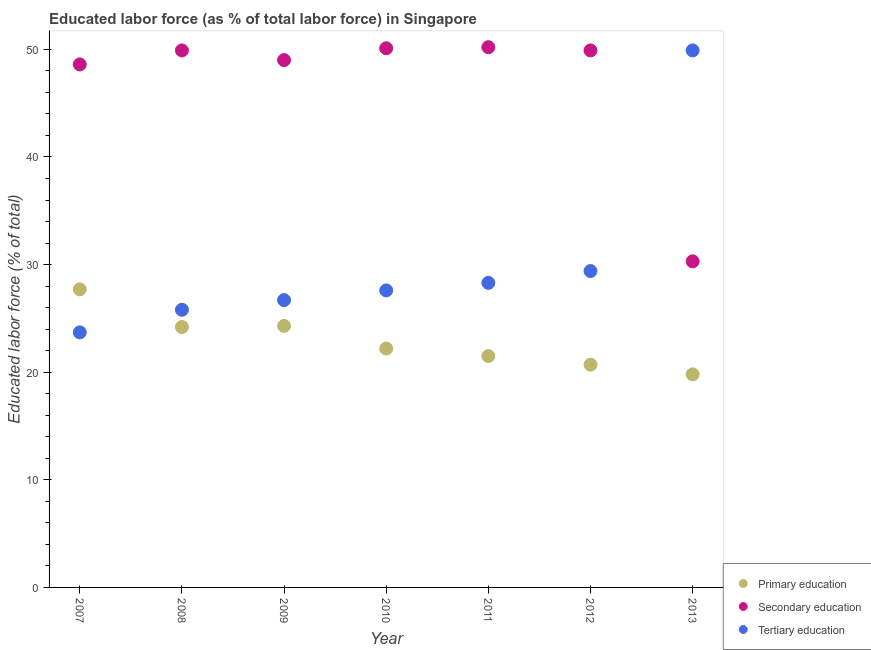What is the percentage of labor force who received primary education in 2008?
Your answer should be very brief. 24.2. Across all years, what is the maximum percentage of labor force who received primary education?
Ensure brevity in your answer.  27.7. Across all years, what is the minimum percentage of labor force who received secondary education?
Your answer should be compact. 30.3. In which year was the percentage of labor force who received secondary education minimum?
Offer a terse response. 2013. What is the total percentage of labor force who received primary education in the graph?
Your answer should be compact. 160.4. What is the difference between the percentage of labor force who received secondary education in 2008 and that in 2010?
Keep it short and to the point. -0.2. What is the difference between the percentage of labor force who received tertiary education in 2007 and the percentage of labor force who received primary education in 2008?
Offer a very short reply. -0.5. What is the average percentage of labor force who received primary education per year?
Ensure brevity in your answer.  22.91. In the year 2008, what is the difference between the percentage of labor force who received secondary education and percentage of labor force who received primary education?
Offer a terse response. 25.7. What is the ratio of the percentage of labor force who received secondary education in 2010 to that in 2013?
Provide a succinct answer. 1.65. What is the difference between the highest and the second highest percentage of labor force who received secondary education?
Offer a very short reply. 0.1. What is the difference between the highest and the lowest percentage of labor force who received tertiary education?
Offer a very short reply. 26.2. In how many years, is the percentage of labor force who received primary education greater than the average percentage of labor force who received primary education taken over all years?
Ensure brevity in your answer.  3. Is it the case that in every year, the sum of the percentage of labor force who received primary education and percentage of labor force who received secondary education is greater than the percentage of labor force who received tertiary education?
Offer a very short reply. Yes. Is the percentage of labor force who received secondary education strictly greater than the percentage of labor force who received tertiary education over the years?
Your answer should be compact. No. Is the percentage of labor force who received tertiary education strictly less than the percentage of labor force who received secondary education over the years?
Ensure brevity in your answer.  No. What is the difference between two consecutive major ticks on the Y-axis?
Make the answer very short. 10. Are the values on the major ticks of Y-axis written in scientific E-notation?
Your answer should be compact. No. Does the graph contain any zero values?
Keep it short and to the point. No. Does the graph contain grids?
Ensure brevity in your answer.  No. Where does the legend appear in the graph?
Offer a very short reply. Bottom right. How many legend labels are there?
Give a very brief answer. 3. How are the legend labels stacked?
Offer a very short reply. Vertical. What is the title of the graph?
Make the answer very short. Educated labor force (as % of total labor force) in Singapore. What is the label or title of the X-axis?
Give a very brief answer. Year. What is the label or title of the Y-axis?
Your answer should be compact. Educated labor force (% of total). What is the Educated labor force (% of total) in Primary education in 2007?
Offer a terse response. 27.7. What is the Educated labor force (% of total) of Secondary education in 2007?
Your answer should be very brief. 48.6. What is the Educated labor force (% of total) in Tertiary education in 2007?
Offer a very short reply. 23.7. What is the Educated labor force (% of total) of Primary education in 2008?
Your response must be concise. 24.2. What is the Educated labor force (% of total) in Secondary education in 2008?
Make the answer very short. 49.9. What is the Educated labor force (% of total) in Tertiary education in 2008?
Make the answer very short. 25.8. What is the Educated labor force (% of total) of Primary education in 2009?
Your answer should be compact. 24.3. What is the Educated labor force (% of total) in Secondary education in 2009?
Your answer should be compact. 49. What is the Educated labor force (% of total) of Tertiary education in 2009?
Your response must be concise. 26.7. What is the Educated labor force (% of total) of Primary education in 2010?
Provide a succinct answer. 22.2. What is the Educated labor force (% of total) of Secondary education in 2010?
Offer a very short reply. 50.1. What is the Educated labor force (% of total) in Tertiary education in 2010?
Your answer should be compact. 27.6. What is the Educated labor force (% of total) in Primary education in 2011?
Provide a short and direct response. 21.5. What is the Educated labor force (% of total) of Secondary education in 2011?
Provide a short and direct response. 50.2. What is the Educated labor force (% of total) of Tertiary education in 2011?
Your answer should be very brief. 28.3. What is the Educated labor force (% of total) in Primary education in 2012?
Offer a terse response. 20.7. What is the Educated labor force (% of total) of Secondary education in 2012?
Make the answer very short. 49.9. What is the Educated labor force (% of total) of Tertiary education in 2012?
Your answer should be compact. 29.4. What is the Educated labor force (% of total) of Primary education in 2013?
Provide a short and direct response. 19.8. What is the Educated labor force (% of total) in Secondary education in 2013?
Your answer should be compact. 30.3. What is the Educated labor force (% of total) in Tertiary education in 2013?
Make the answer very short. 49.9. Across all years, what is the maximum Educated labor force (% of total) in Primary education?
Provide a succinct answer. 27.7. Across all years, what is the maximum Educated labor force (% of total) of Secondary education?
Keep it short and to the point. 50.2. Across all years, what is the maximum Educated labor force (% of total) of Tertiary education?
Keep it short and to the point. 49.9. Across all years, what is the minimum Educated labor force (% of total) of Primary education?
Offer a terse response. 19.8. Across all years, what is the minimum Educated labor force (% of total) in Secondary education?
Your response must be concise. 30.3. Across all years, what is the minimum Educated labor force (% of total) of Tertiary education?
Make the answer very short. 23.7. What is the total Educated labor force (% of total) in Primary education in the graph?
Ensure brevity in your answer.  160.4. What is the total Educated labor force (% of total) in Secondary education in the graph?
Offer a very short reply. 328. What is the total Educated labor force (% of total) in Tertiary education in the graph?
Your response must be concise. 211.4. What is the difference between the Educated labor force (% of total) in Secondary education in 2007 and that in 2009?
Offer a very short reply. -0.4. What is the difference between the Educated labor force (% of total) of Tertiary education in 2007 and that in 2009?
Your response must be concise. -3. What is the difference between the Educated labor force (% of total) of Tertiary education in 2007 and that in 2010?
Provide a short and direct response. -3.9. What is the difference between the Educated labor force (% of total) in Primary education in 2007 and that in 2012?
Keep it short and to the point. 7. What is the difference between the Educated labor force (% of total) in Secondary education in 2007 and that in 2012?
Provide a short and direct response. -1.3. What is the difference between the Educated labor force (% of total) of Primary education in 2007 and that in 2013?
Offer a terse response. 7.9. What is the difference between the Educated labor force (% of total) in Secondary education in 2007 and that in 2013?
Your response must be concise. 18.3. What is the difference between the Educated labor force (% of total) in Tertiary education in 2007 and that in 2013?
Give a very brief answer. -26.2. What is the difference between the Educated labor force (% of total) of Primary education in 2008 and that in 2009?
Offer a terse response. -0.1. What is the difference between the Educated labor force (% of total) in Tertiary education in 2008 and that in 2009?
Keep it short and to the point. -0.9. What is the difference between the Educated labor force (% of total) in Secondary education in 2008 and that in 2010?
Provide a short and direct response. -0.2. What is the difference between the Educated labor force (% of total) of Tertiary education in 2008 and that in 2010?
Provide a short and direct response. -1.8. What is the difference between the Educated labor force (% of total) of Primary education in 2008 and that in 2011?
Ensure brevity in your answer.  2.7. What is the difference between the Educated labor force (% of total) of Tertiary education in 2008 and that in 2011?
Ensure brevity in your answer.  -2.5. What is the difference between the Educated labor force (% of total) of Primary education in 2008 and that in 2012?
Give a very brief answer. 3.5. What is the difference between the Educated labor force (% of total) in Tertiary education in 2008 and that in 2012?
Offer a very short reply. -3.6. What is the difference between the Educated labor force (% of total) of Secondary education in 2008 and that in 2013?
Keep it short and to the point. 19.6. What is the difference between the Educated labor force (% of total) in Tertiary education in 2008 and that in 2013?
Ensure brevity in your answer.  -24.1. What is the difference between the Educated labor force (% of total) of Primary education in 2009 and that in 2010?
Make the answer very short. 2.1. What is the difference between the Educated labor force (% of total) in Secondary education in 2009 and that in 2010?
Your answer should be very brief. -1.1. What is the difference between the Educated labor force (% of total) of Tertiary education in 2009 and that in 2010?
Keep it short and to the point. -0.9. What is the difference between the Educated labor force (% of total) of Primary education in 2009 and that in 2012?
Your answer should be very brief. 3.6. What is the difference between the Educated labor force (% of total) in Primary education in 2009 and that in 2013?
Your answer should be very brief. 4.5. What is the difference between the Educated labor force (% of total) in Tertiary education in 2009 and that in 2013?
Your answer should be very brief. -23.2. What is the difference between the Educated labor force (% of total) of Secondary education in 2010 and that in 2011?
Ensure brevity in your answer.  -0.1. What is the difference between the Educated labor force (% of total) of Secondary education in 2010 and that in 2012?
Give a very brief answer. 0.2. What is the difference between the Educated labor force (% of total) in Tertiary education in 2010 and that in 2012?
Offer a very short reply. -1.8. What is the difference between the Educated labor force (% of total) of Primary education in 2010 and that in 2013?
Give a very brief answer. 2.4. What is the difference between the Educated labor force (% of total) of Secondary education in 2010 and that in 2013?
Give a very brief answer. 19.8. What is the difference between the Educated labor force (% of total) in Tertiary education in 2010 and that in 2013?
Ensure brevity in your answer.  -22.3. What is the difference between the Educated labor force (% of total) in Secondary education in 2011 and that in 2012?
Your answer should be compact. 0.3. What is the difference between the Educated labor force (% of total) of Tertiary education in 2011 and that in 2012?
Provide a short and direct response. -1.1. What is the difference between the Educated labor force (% of total) in Primary education in 2011 and that in 2013?
Provide a short and direct response. 1.7. What is the difference between the Educated labor force (% of total) in Secondary education in 2011 and that in 2013?
Your answer should be compact. 19.9. What is the difference between the Educated labor force (% of total) in Tertiary education in 2011 and that in 2013?
Offer a very short reply. -21.6. What is the difference between the Educated labor force (% of total) of Primary education in 2012 and that in 2013?
Ensure brevity in your answer.  0.9. What is the difference between the Educated labor force (% of total) of Secondary education in 2012 and that in 2013?
Your answer should be compact. 19.6. What is the difference between the Educated labor force (% of total) of Tertiary education in 2012 and that in 2013?
Provide a succinct answer. -20.5. What is the difference between the Educated labor force (% of total) of Primary education in 2007 and the Educated labor force (% of total) of Secondary education in 2008?
Provide a succinct answer. -22.2. What is the difference between the Educated labor force (% of total) in Primary education in 2007 and the Educated labor force (% of total) in Tertiary education in 2008?
Keep it short and to the point. 1.9. What is the difference between the Educated labor force (% of total) in Secondary education in 2007 and the Educated labor force (% of total) in Tertiary education in 2008?
Make the answer very short. 22.8. What is the difference between the Educated labor force (% of total) in Primary education in 2007 and the Educated labor force (% of total) in Secondary education in 2009?
Your answer should be compact. -21.3. What is the difference between the Educated labor force (% of total) of Primary education in 2007 and the Educated labor force (% of total) of Tertiary education in 2009?
Provide a short and direct response. 1. What is the difference between the Educated labor force (% of total) in Secondary education in 2007 and the Educated labor force (% of total) in Tertiary education in 2009?
Provide a succinct answer. 21.9. What is the difference between the Educated labor force (% of total) in Primary education in 2007 and the Educated labor force (% of total) in Secondary education in 2010?
Give a very brief answer. -22.4. What is the difference between the Educated labor force (% of total) of Primary education in 2007 and the Educated labor force (% of total) of Tertiary education in 2010?
Your response must be concise. 0.1. What is the difference between the Educated labor force (% of total) of Primary education in 2007 and the Educated labor force (% of total) of Secondary education in 2011?
Give a very brief answer. -22.5. What is the difference between the Educated labor force (% of total) in Primary education in 2007 and the Educated labor force (% of total) in Tertiary education in 2011?
Make the answer very short. -0.6. What is the difference between the Educated labor force (% of total) in Secondary education in 2007 and the Educated labor force (% of total) in Tertiary education in 2011?
Keep it short and to the point. 20.3. What is the difference between the Educated labor force (% of total) in Primary education in 2007 and the Educated labor force (% of total) in Secondary education in 2012?
Give a very brief answer. -22.2. What is the difference between the Educated labor force (% of total) of Secondary education in 2007 and the Educated labor force (% of total) of Tertiary education in 2012?
Your answer should be compact. 19.2. What is the difference between the Educated labor force (% of total) of Primary education in 2007 and the Educated labor force (% of total) of Tertiary education in 2013?
Your answer should be compact. -22.2. What is the difference between the Educated labor force (% of total) in Primary education in 2008 and the Educated labor force (% of total) in Secondary education in 2009?
Give a very brief answer. -24.8. What is the difference between the Educated labor force (% of total) of Primary education in 2008 and the Educated labor force (% of total) of Tertiary education in 2009?
Offer a very short reply. -2.5. What is the difference between the Educated labor force (% of total) in Secondary education in 2008 and the Educated labor force (% of total) in Tertiary education in 2009?
Ensure brevity in your answer.  23.2. What is the difference between the Educated labor force (% of total) in Primary education in 2008 and the Educated labor force (% of total) in Secondary education in 2010?
Your response must be concise. -25.9. What is the difference between the Educated labor force (% of total) in Secondary education in 2008 and the Educated labor force (% of total) in Tertiary education in 2010?
Your answer should be very brief. 22.3. What is the difference between the Educated labor force (% of total) of Primary education in 2008 and the Educated labor force (% of total) of Secondary education in 2011?
Make the answer very short. -26. What is the difference between the Educated labor force (% of total) of Primary education in 2008 and the Educated labor force (% of total) of Tertiary education in 2011?
Offer a very short reply. -4.1. What is the difference between the Educated labor force (% of total) in Secondary education in 2008 and the Educated labor force (% of total) in Tertiary education in 2011?
Your answer should be compact. 21.6. What is the difference between the Educated labor force (% of total) of Primary education in 2008 and the Educated labor force (% of total) of Secondary education in 2012?
Your answer should be very brief. -25.7. What is the difference between the Educated labor force (% of total) of Primary education in 2008 and the Educated labor force (% of total) of Secondary education in 2013?
Your answer should be very brief. -6.1. What is the difference between the Educated labor force (% of total) of Primary education in 2008 and the Educated labor force (% of total) of Tertiary education in 2013?
Provide a succinct answer. -25.7. What is the difference between the Educated labor force (% of total) of Secondary education in 2008 and the Educated labor force (% of total) of Tertiary education in 2013?
Your answer should be compact. 0. What is the difference between the Educated labor force (% of total) of Primary education in 2009 and the Educated labor force (% of total) of Secondary education in 2010?
Your response must be concise. -25.8. What is the difference between the Educated labor force (% of total) of Primary education in 2009 and the Educated labor force (% of total) of Tertiary education in 2010?
Provide a succinct answer. -3.3. What is the difference between the Educated labor force (% of total) in Secondary education in 2009 and the Educated labor force (% of total) in Tertiary education in 2010?
Your response must be concise. 21.4. What is the difference between the Educated labor force (% of total) of Primary education in 2009 and the Educated labor force (% of total) of Secondary education in 2011?
Keep it short and to the point. -25.9. What is the difference between the Educated labor force (% of total) of Primary education in 2009 and the Educated labor force (% of total) of Tertiary education in 2011?
Your answer should be compact. -4. What is the difference between the Educated labor force (% of total) of Secondary education in 2009 and the Educated labor force (% of total) of Tertiary education in 2011?
Your answer should be very brief. 20.7. What is the difference between the Educated labor force (% of total) of Primary education in 2009 and the Educated labor force (% of total) of Secondary education in 2012?
Keep it short and to the point. -25.6. What is the difference between the Educated labor force (% of total) in Primary education in 2009 and the Educated labor force (% of total) in Tertiary education in 2012?
Make the answer very short. -5.1. What is the difference between the Educated labor force (% of total) in Secondary education in 2009 and the Educated labor force (% of total) in Tertiary education in 2012?
Offer a terse response. 19.6. What is the difference between the Educated labor force (% of total) of Primary education in 2009 and the Educated labor force (% of total) of Secondary education in 2013?
Make the answer very short. -6. What is the difference between the Educated labor force (% of total) of Primary education in 2009 and the Educated labor force (% of total) of Tertiary education in 2013?
Make the answer very short. -25.6. What is the difference between the Educated labor force (% of total) in Secondary education in 2009 and the Educated labor force (% of total) in Tertiary education in 2013?
Make the answer very short. -0.9. What is the difference between the Educated labor force (% of total) of Secondary education in 2010 and the Educated labor force (% of total) of Tertiary education in 2011?
Your answer should be compact. 21.8. What is the difference between the Educated labor force (% of total) of Primary education in 2010 and the Educated labor force (% of total) of Secondary education in 2012?
Your answer should be very brief. -27.7. What is the difference between the Educated labor force (% of total) of Primary education in 2010 and the Educated labor force (% of total) of Tertiary education in 2012?
Ensure brevity in your answer.  -7.2. What is the difference between the Educated labor force (% of total) in Secondary education in 2010 and the Educated labor force (% of total) in Tertiary education in 2012?
Provide a short and direct response. 20.7. What is the difference between the Educated labor force (% of total) of Primary education in 2010 and the Educated labor force (% of total) of Tertiary education in 2013?
Provide a succinct answer. -27.7. What is the difference between the Educated labor force (% of total) of Primary education in 2011 and the Educated labor force (% of total) of Secondary education in 2012?
Make the answer very short. -28.4. What is the difference between the Educated labor force (% of total) in Secondary education in 2011 and the Educated labor force (% of total) in Tertiary education in 2012?
Provide a succinct answer. 20.8. What is the difference between the Educated labor force (% of total) in Primary education in 2011 and the Educated labor force (% of total) in Tertiary education in 2013?
Provide a succinct answer. -28.4. What is the difference between the Educated labor force (% of total) in Primary education in 2012 and the Educated labor force (% of total) in Tertiary education in 2013?
Keep it short and to the point. -29.2. What is the difference between the Educated labor force (% of total) of Secondary education in 2012 and the Educated labor force (% of total) of Tertiary education in 2013?
Provide a short and direct response. 0. What is the average Educated labor force (% of total) in Primary education per year?
Make the answer very short. 22.91. What is the average Educated labor force (% of total) of Secondary education per year?
Give a very brief answer. 46.86. What is the average Educated labor force (% of total) in Tertiary education per year?
Give a very brief answer. 30.2. In the year 2007, what is the difference between the Educated labor force (% of total) in Primary education and Educated labor force (% of total) in Secondary education?
Provide a short and direct response. -20.9. In the year 2007, what is the difference between the Educated labor force (% of total) of Secondary education and Educated labor force (% of total) of Tertiary education?
Your response must be concise. 24.9. In the year 2008, what is the difference between the Educated labor force (% of total) in Primary education and Educated labor force (% of total) in Secondary education?
Offer a terse response. -25.7. In the year 2008, what is the difference between the Educated labor force (% of total) of Secondary education and Educated labor force (% of total) of Tertiary education?
Offer a terse response. 24.1. In the year 2009, what is the difference between the Educated labor force (% of total) of Primary education and Educated labor force (% of total) of Secondary education?
Give a very brief answer. -24.7. In the year 2009, what is the difference between the Educated labor force (% of total) in Primary education and Educated labor force (% of total) in Tertiary education?
Provide a short and direct response. -2.4. In the year 2009, what is the difference between the Educated labor force (% of total) of Secondary education and Educated labor force (% of total) of Tertiary education?
Give a very brief answer. 22.3. In the year 2010, what is the difference between the Educated labor force (% of total) in Primary education and Educated labor force (% of total) in Secondary education?
Offer a terse response. -27.9. In the year 2011, what is the difference between the Educated labor force (% of total) of Primary education and Educated labor force (% of total) of Secondary education?
Make the answer very short. -28.7. In the year 2011, what is the difference between the Educated labor force (% of total) in Secondary education and Educated labor force (% of total) in Tertiary education?
Your answer should be compact. 21.9. In the year 2012, what is the difference between the Educated labor force (% of total) in Primary education and Educated labor force (% of total) in Secondary education?
Offer a terse response. -29.2. In the year 2012, what is the difference between the Educated labor force (% of total) of Secondary education and Educated labor force (% of total) of Tertiary education?
Provide a short and direct response. 20.5. In the year 2013, what is the difference between the Educated labor force (% of total) in Primary education and Educated labor force (% of total) in Secondary education?
Give a very brief answer. -10.5. In the year 2013, what is the difference between the Educated labor force (% of total) of Primary education and Educated labor force (% of total) of Tertiary education?
Provide a short and direct response. -30.1. In the year 2013, what is the difference between the Educated labor force (% of total) of Secondary education and Educated labor force (% of total) of Tertiary education?
Make the answer very short. -19.6. What is the ratio of the Educated labor force (% of total) of Primary education in 2007 to that in 2008?
Provide a succinct answer. 1.14. What is the ratio of the Educated labor force (% of total) of Secondary education in 2007 to that in 2008?
Give a very brief answer. 0.97. What is the ratio of the Educated labor force (% of total) of Tertiary education in 2007 to that in 2008?
Make the answer very short. 0.92. What is the ratio of the Educated labor force (% of total) in Primary education in 2007 to that in 2009?
Offer a terse response. 1.14. What is the ratio of the Educated labor force (% of total) in Tertiary education in 2007 to that in 2009?
Ensure brevity in your answer.  0.89. What is the ratio of the Educated labor force (% of total) of Primary education in 2007 to that in 2010?
Your answer should be compact. 1.25. What is the ratio of the Educated labor force (% of total) in Secondary education in 2007 to that in 2010?
Ensure brevity in your answer.  0.97. What is the ratio of the Educated labor force (% of total) of Tertiary education in 2007 to that in 2010?
Your answer should be very brief. 0.86. What is the ratio of the Educated labor force (% of total) in Primary education in 2007 to that in 2011?
Keep it short and to the point. 1.29. What is the ratio of the Educated labor force (% of total) of Secondary education in 2007 to that in 2011?
Your answer should be very brief. 0.97. What is the ratio of the Educated labor force (% of total) in Tertiary education in 2007 to that in 2011?
Give a very brief answer. 0.84. What is the ratio of the Educated labor force (% of total) of Primary education in 2007 to that in 2012?
Your response must be concise. 1.34. What is the ratio of the Educated labor force (% of total) of Secondary education in 2007 to that in 2012?
Provide a short and direct response. 0.97. What is the ratio of the Educated labor force (% of total) of Tertiary education in 2007 to that in 2012?
Keep it short and to the point. 0.81. What is the ratio of the Educated labor force (% of total) of Primary education in 2007 to that in 2013?
Your response must be concise. 1.4. What is the ratio of the Educated labor force (% of total) of Secondary education in 2007 to that in 2013?
Your answer should be very brief. 1.6. What is the ratio of the Educated labor force (% of total) of Tertiary education in 2007 to that in 2013?
Offer a very short reply. 0.47. What is the ratio of the Educated labor force (% of total) in Secondary education in 2008 to that in 2009?
Provide a succinct answer. 1.02. What is the ratio of the Educated labor force (% of total) in Tertiary education in 2008 to that in 2009?
Provide a short and direct response. 0.97. What is the ratio of the Educated labor force (% of total) of Primary education in 2008 to that in 2010?
Offer a terse response. 1.09. What is the ratio of the Educated labor force (% of total) of Secondary education in 2008 to that in 2010?
Provide a short and direct response. 1. What is the ratio of the Educated labor force (% of total) in Tertiary education in 2008 to that in 2010?
Your answer should be compact. 0.93. What is the ratio of the Educated labor force (% of total) of Primary education in 2008 to that in 2011?
Make the answer very short. 1.13. What is the ratio of the Educated labor force (% of total) in Tertiary education in 2008 to that in 2011?
Make the answer very short. 0.91. What is the ratio of the Educated labor force (% of total) in Primary education in 2008 to that in 2012?
Offer a terse response. 1.17. What is the ratio of the Educated labor force (% of total) in Secondary education in 2008 to that in 2012?
Your answer should be compact. 1. What is the ratio of the Educated labor force (% of total) of Tertiary education in 2008 to that in 2012?
Make the answer very short. 0.88. What is the ratio of the Educated labor force (% of total) in Primary education in 2008 to that in 2013?
Provide a short and direct response. 1.22. What is the ratio of the Educated labor force (% of total) in Secondary education in 2008 to that in 2013?
Give a very brief answer. 1.65. What is the ratio of the Educated labor force (% of total) in Tertiary education in 2008 to that in 2013?
Your answer should be very brief. 0.52. What is the ratio of the Educated labor force (% of total) in Primary education in 2009 to that in 2010?
Your response must be concise. 1.09. What is the ratio of the Educated labor force (% of total) of Tertiary education in 2009 to that in 2010?
Ensure brevity in your answer.  0.97. What is the ratio of the Educated labor force (% of total) in Primary education in 2009 to that in 2011?
Offer a terse response. 1.13. What is the ratio of the Educated labor force (% of total) in Secondary education in 2009 to that in 2011?
Ensure brevity in your answer.  0.98. What is the ratio of the Educated labor force (% of total) in Tertiary education in 2009 to that in 2011?
Your answer should be very brief. 0.94. What is the ratio of the Educated labor force (% of total) in Primary education in 2009 to that in 2012?
Offer a very short reply. 1.17. What is the ratio of the Educated labor force (% of total) in Secondary education in 2009 to that in 2012?
Provide a short and direct response. 0.98. What is the ratio of the Educated labor force (% of total) of Tertiary education in 2009 to that in 2012?
Give a very brief answer. 0.91. What is the ratio of the Educated labor force (% of total) of Primary education in 2009 to that in 2013?
Your answer should be compact. 1.23. What is the ratio of the Educated labor force (% of total) of Secondary education in 2009 to that in 2013?
Make the answer very short. 1.62. What is the ratio of the Educated labor force (% of total) of Tertiary education in 2009 to that in 2013?
Offer a terse response. 0.54. What is the ratio of the Educated labor force (% of total) in Primary education in 2010 to that in 2011?
Your response must be concise. 1.03. What is the ratio of the Educated labor force (% of total) of Tertiary education in 2010 to that in 2011?
Your answer should be compact. 0.98. What is the ratio of the Educated labor force (% of total) in Primary education in 2010 to that in 2012?
Provide a short and direct response. 1.07. What is the ratio of the Educated labor force (% of total) in Secondary education in 2010 to that in 2012?
Ensure brevity in your answer.  1. What is the ratio of the Educated labor force (% of total) in Tertiary education in 2010 to that in 2012?
Offer a terse response. 0.94. What is the ratio of the Educated labor force (% of total) of Primary education in 2010 to that in 2013?
Offer a very short reply. 1.12. What is the ratio of the Educated labor force (% of total) in Secondary education in 2010 to that in 2013?
Your answer should be very brief. 1.65. What is the ratio of the Educated labor force (% of total) in Tertiary education in 2010 to that in 2013?
Provide a short and direct response. 0.55. What is the ratio of the Educated labor force (% of total) in Primary education in 2011 to that in 2012?
Your response must be concise. 1.04. What is the ratio of the Educated labor force (% of total) of Tertiary education in 2011 to that in 2012?
Offer a very short reply. 0.96. What is the ratio of the Educated labor force (% of total) of Primary education in 2011 to that in 2013?
Make the answer very short. 1.09. What is the ratio of the Educated labor force (% of total) in Secondary education in 2011 to that in 2013?
Offer a very short reply. 1.66. What is the ratio of the Educated labor force (% of total) in Tertiary education in 2011 to that in 2013?
Provide a short and direct response. 0.57. What is the ratio of the Educated labor force (% of total) of Primary education in 2012 to that in 2013?
Make the answer very short. 1.05. What is the ratio of the Educated labor force (% of total) in Secondary education in 2012 to that in 2013?
Provide a short and direct response. 1.65. What is the ratio of the Educated labor force (% of total) of Tertiary education in 2012 to that in 2013?
Your answer should be very brief. 0.59. What is the difference between the highest and the second highest Educated labor force (% of total) in Tertiary education?
Your response must be concise. 20.5. What is the difference between the highest and the lowest Educated labor force (% of total) of Secondary education?
Offer a very short reply. 19.9. What is the difference between the highest and the lowest Educated labor force (% of total) in Tertiary education?
Ensure brevity in your answer.  26.2. 